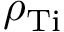Convert formula to latex. <formula><loc_0><loc_0><loc_500><loc_500>\rho _ { T i }</formula> 